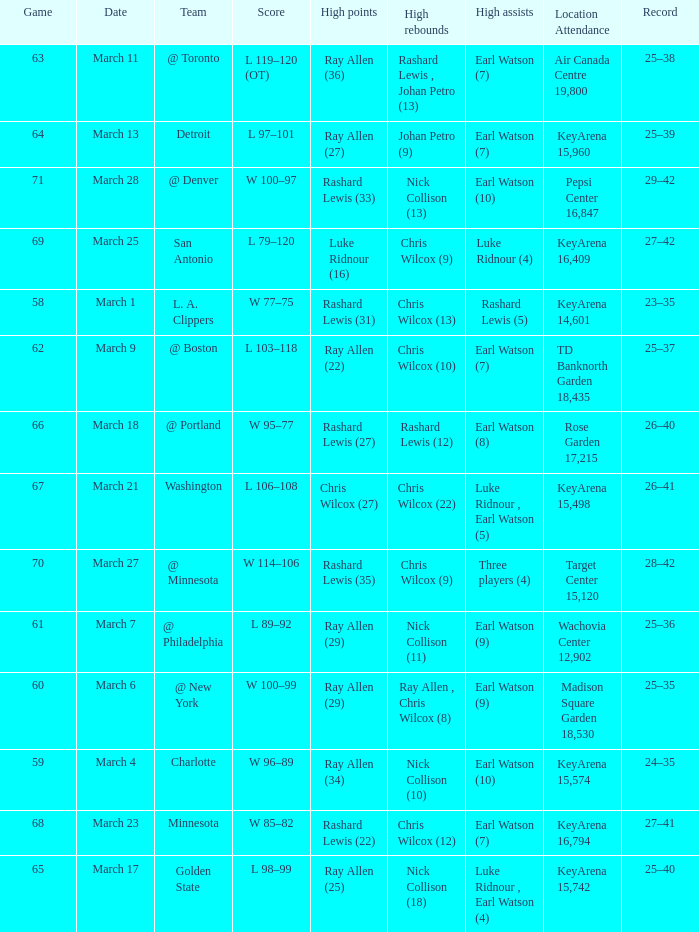Who had the most points in the game on March 7? Ray Allen (29). 